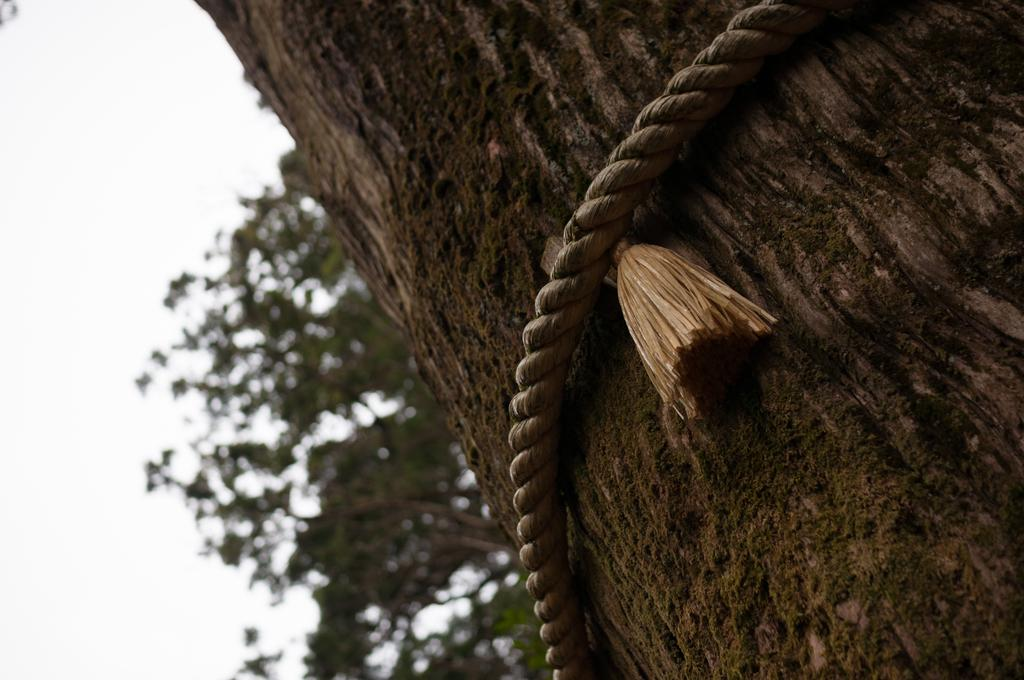What object can be seen in the image that is used for tying or securing? There is a rope in the image that is used for tying or securing. What is the rope tied to in the image? The rope is tied to a tree in the image. What type of vegetation can be seen in the background of the image? There are green leaves in the background of the image. Can you tell me how many beggars are sitting under the tree in the image? There are no beggars present in the image; it only features a rope tied to a tree and green leaves in the background. What type of connection is established between the rope and the tree in the image? The rope is physically tied to the tree, creating a connection between the two objects. 